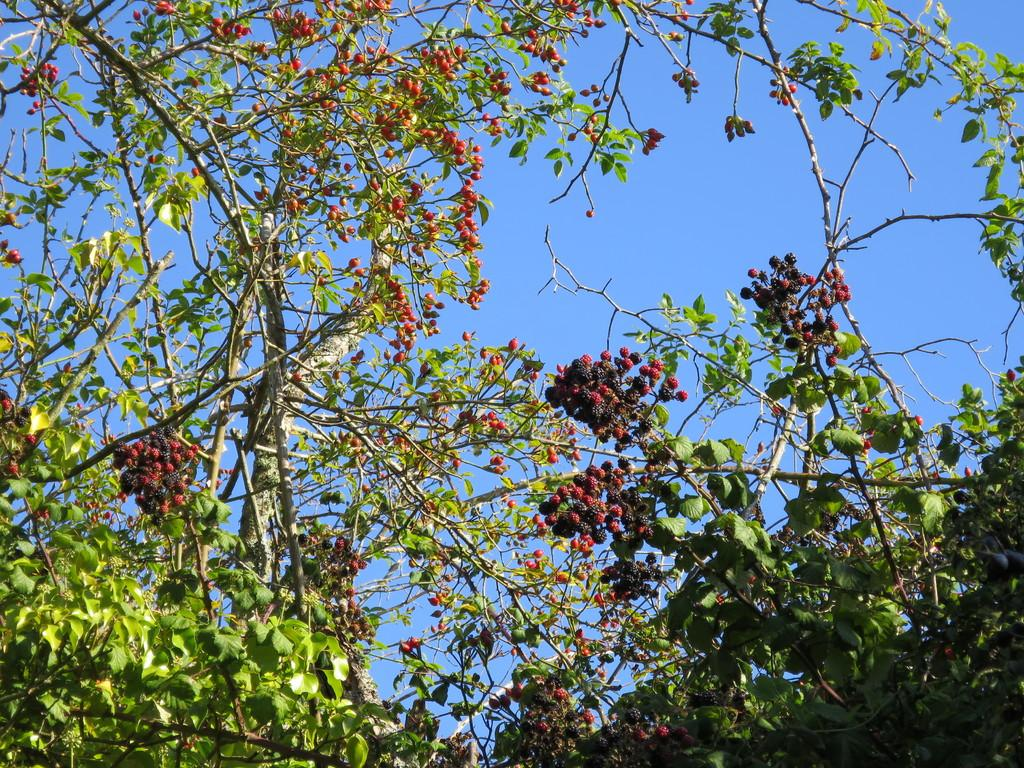What type of plants can be seen in the image? There are trees with fruits in the image. What can be seen in the background of the image? The sky is visible in the background of the image. What type of teeth can be seen in the image? There are no teeth present in the image; it features trees with fruits and a sky background. 